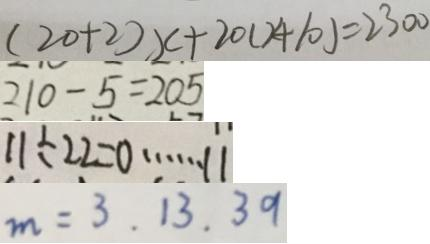<formula> <loc_0><loc_0><loc_500><loc_500>( 2 0 + 2 ) x + 2 0 ( x + 1 0 ) = 2 3 0 0 
 2 1 0 - 5 = 2 0 5 
 1 1 \div 2 2 = 0 \cdots 1 1 
 m = 3 . 1 3 . 3 9</formula> 